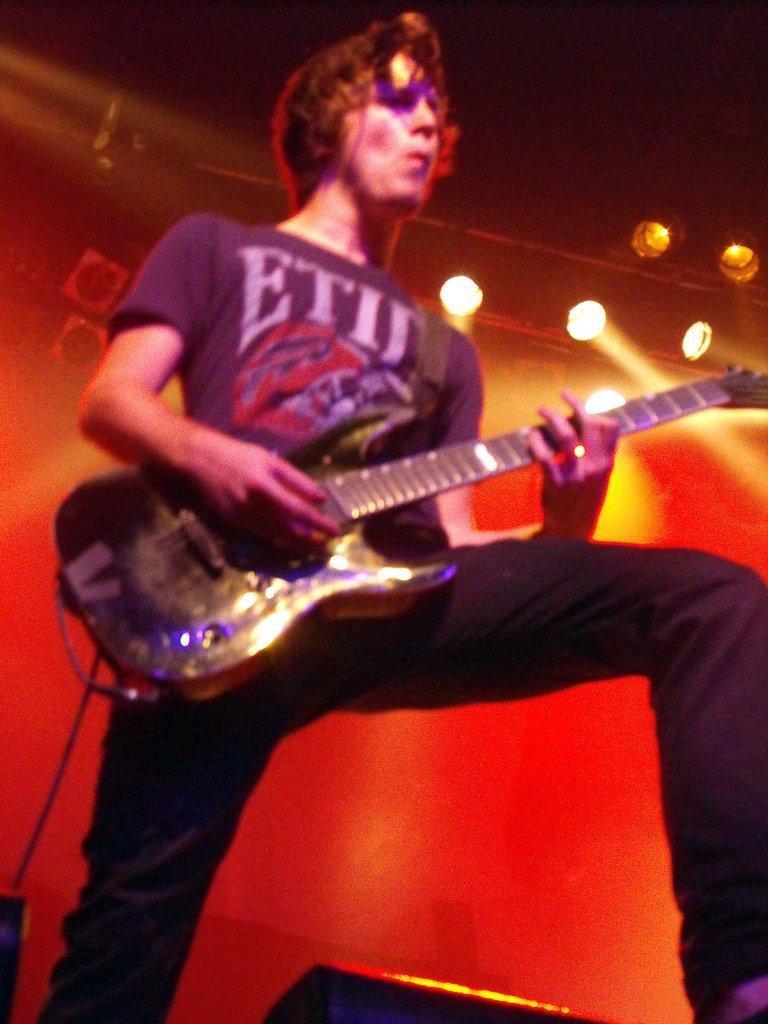In one or two sentences, can you explain what this image depicts? As we can see in the image there are lights and a man holding guitar. 